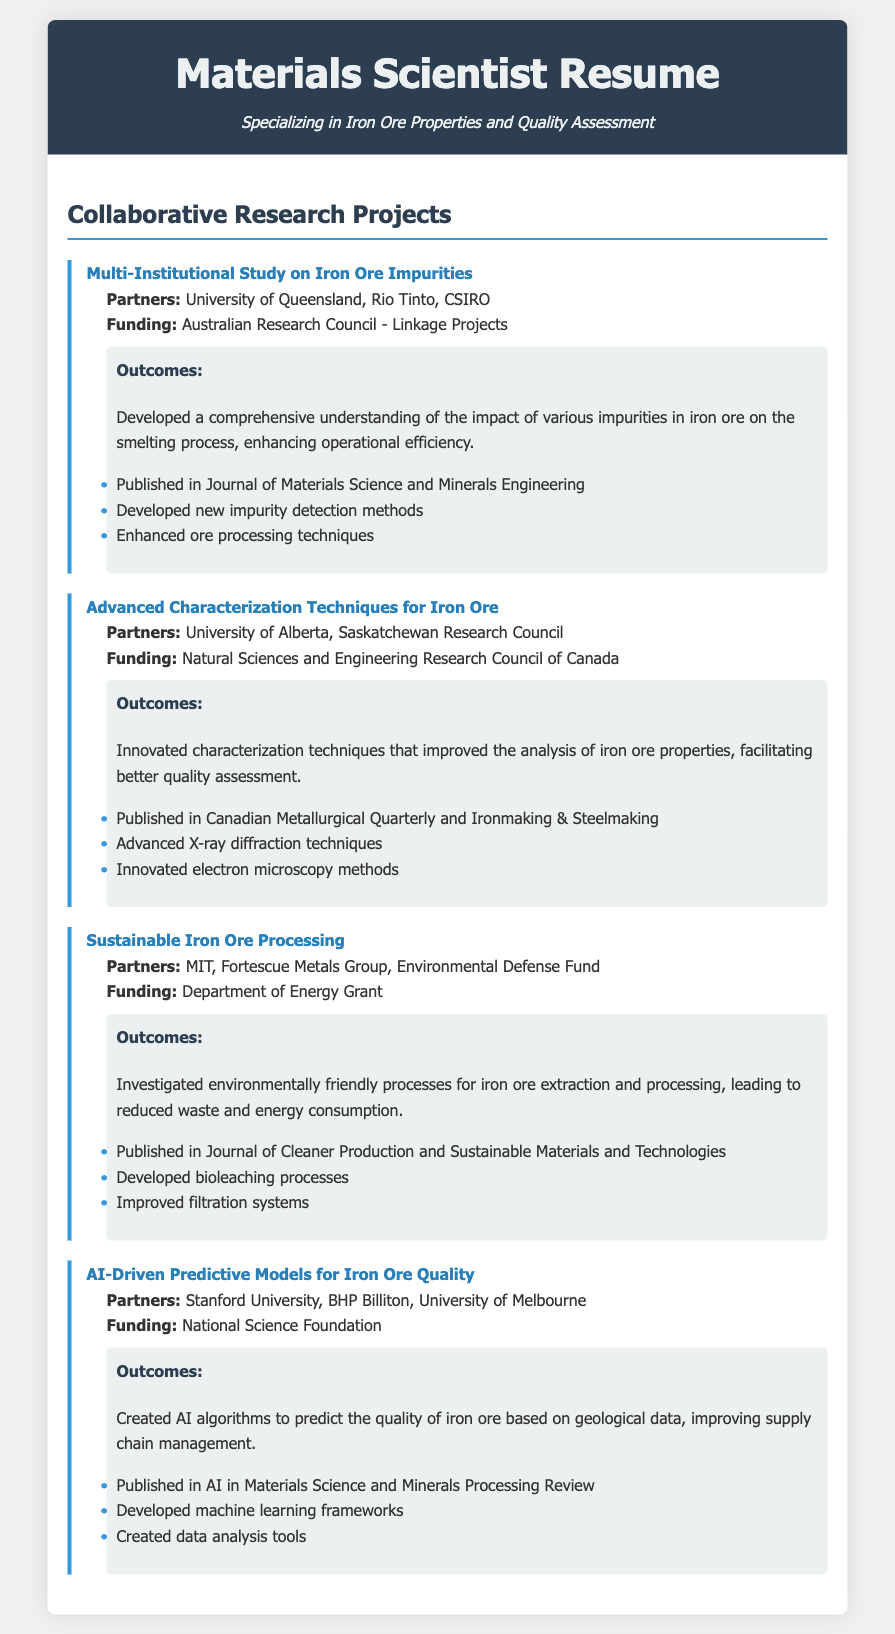What is the title of the first project? The title of the first project is stated clearly in the document as "Multi-Institutional Study on Iron Ore Impurities."
Answer: Multi-Institutional Study on Iron Ore Impurities Who are the partners in the sustainable iron ore processing project? The partners in the sustainable iron ore processing project are listed in the document.
Answer: MIT, Fortescue Metals Group, Environmental Defense Fund What type of funding was received for the advanced characterization techniques project? The funding source for the advanced characterization techniques project is explicitly mentioned.
Answer: Natural Sciences and Engineering Research Council of Canada Which publication featured the outcomes of the AI-driven predictive models project? The document specifies a publication related to the AI-driven predictive models project outcomes.
Answer: AI in Materials Science and Minerals Processing Review How many projects are detailed in the resume? The number of projects can be determined by counting the entries listed in the section.
Answer: Four What was the primary outcome of the multi-institutional study? The primary outcome is described in a summary within the project details, focusing on the impact of impurities.
Answer: Developed a comprehensive understanding of the impact of various impurities in iron ore on the smelting process Which institution collaborated with Rio Tinto in the first project? The collaboration with Rio Tinto includes a specific partner mentioned in the document.
Answer: University of Queensland What funding source is associated with the sustainable iron ore processing project? The document states the funding source directly related to the sustainable iron ore processing project.
Answer: Department of Energy Grant 